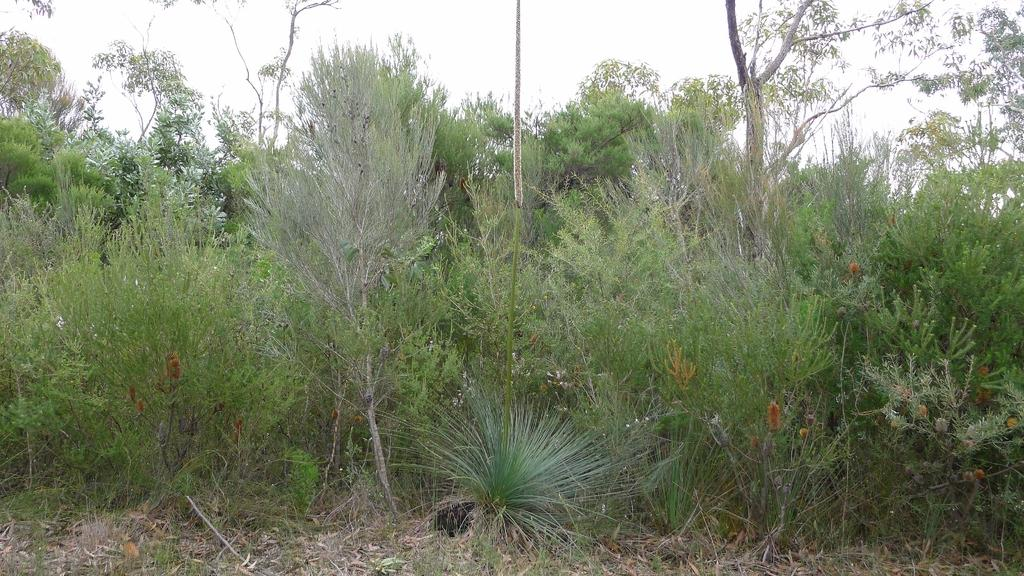What types of vegetation can be seen in the image? There are plants and trees in the image. What features can be observed on the trees? The trees have branches and leaves. What is present on the ground in the image? There are dried leaves lying on the ground in the image. What type of star can be seen in the image? There is no star visible in the image; it features plants, trees, and dried leaves on the ground. What kind of apparatus is being used to maintain the condition of the trees? There is no apparatus present in the image, and no specific condition of the trees is mentioned. 